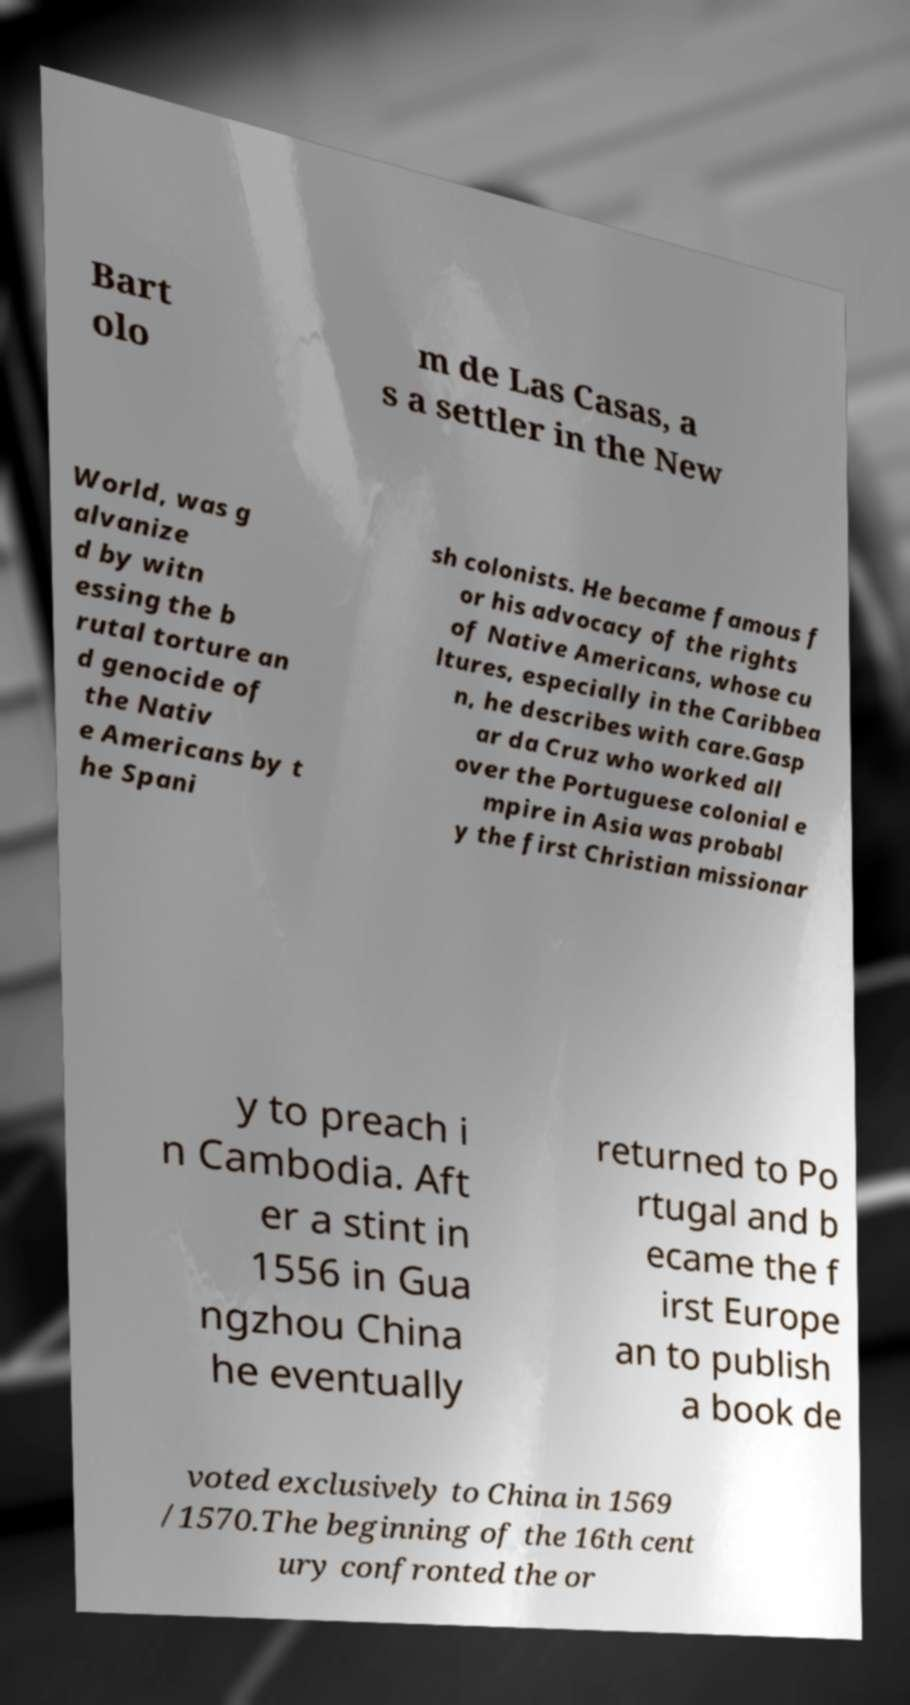Could you extract and type out the text from this image? Bart olo m de Las Casas, a s a settler in the New World, was g alvanize d by witn essing the b rutal torture an d genocide of the Nativ e Americans by t he Spani sh colonists. He became famous f or his advocacy of the rights of Native Americans, whose cu ltures, especially in the Caribbea n, he describes with care.Gasp ar da Cruz who worked all over the Portuguese colonial e mpire in Asia was probabl y the first Christian missionar y to preach i n Cambodia. Aft er a stint in 1556 in Gua ngzhou China he eventually returned to Po rtugal and b ecame the f irst Europe an to publish a book de voted exclusively to China in 1569 /1570.The beginning of the 16th cent ury confronted the or 